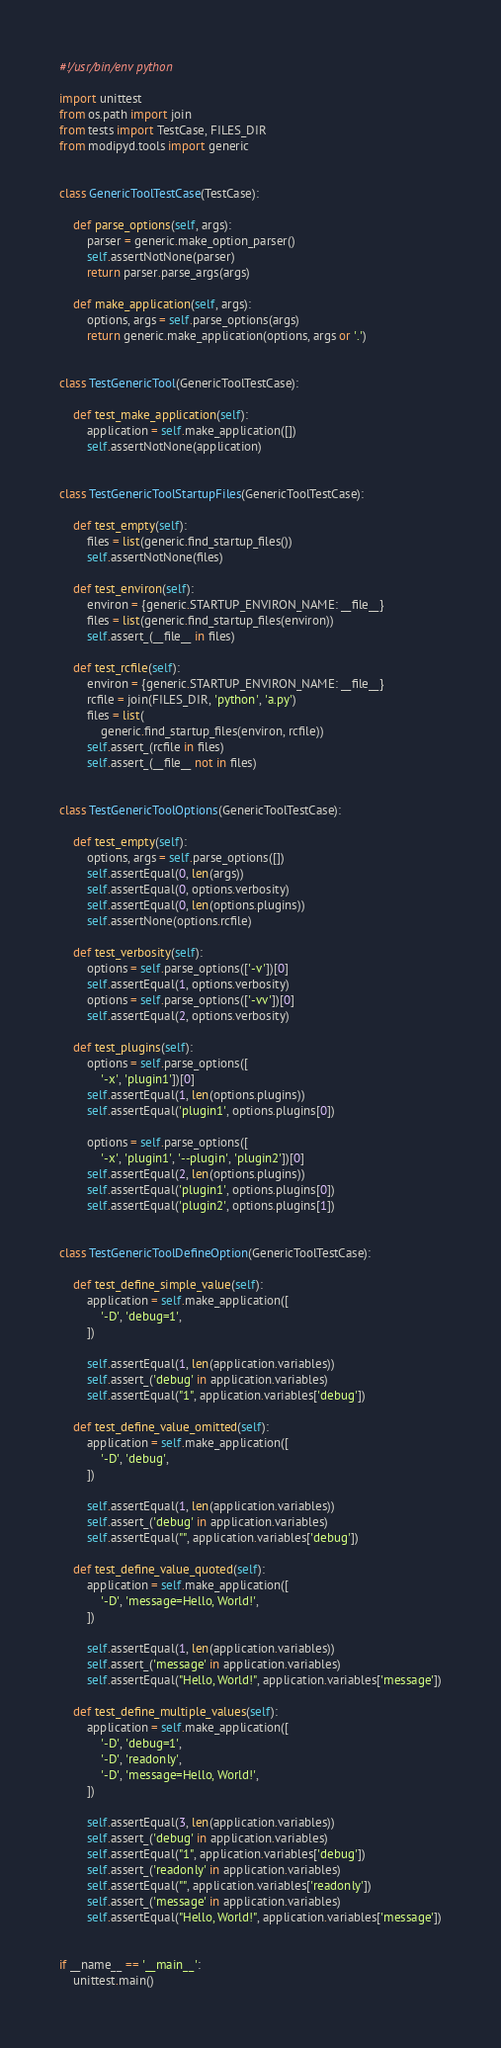<code> <loc_0><loc_0><loc_500><loc_500><_Python_>#!/usr/bin/env python

import unittest
from os.path import join
from tests import TestCase, FILES_DIR
from modipyd.tools import generic


class GenericToolTestCase(TestCase):

    def parse_options(self, args):
        parser = generic.make_option_parser()
        self.assertNotNone(parser)
        return parser.parse_args(args)

    def make_application(self, args):
        options, args = self.parse_options(args)
        return generic.make_application(options, args or '.')


class TestGenericTool(GenericToolTestCase):

    def test_make_application(self):
        application = self.make_application([])
        self.assertNotNone(application)


class TestGenericToolStartupFiles(GenericToolTestCase):

    def test_empty(self):
        files = list(generic.find_startup_files())
        self.assertNotNone(files)

    def test_environ(self):
        environ = {generic.STARTUP_ENVIRON_NAME: __file__}
        files = list(generic.find_startup_files(environ))
        self.assert_(__file__ in files)

    def test_rcfile(self):
        environ = {generic.STARTUP_ENVIRON_NAME: __file__}
        rcfile = join(FILES_DIR, 'python', 'a.py')
        files = list(
            generic.find_startup_files(environ, rcfile))
        self.assert_(rcfile in files)
        self.assert_(__file__ not in files)


class TestGenericToolOptions(GenericToolTestCase):

    def test_empty(self):
        options, args = self.parse_options([])
        self.assertEqual(0, len(args))
        self.assertEqual(0, options.verbosity)
        self.assertEqual(0, len(options.plugins))
        self.assertNone(options.rcfile)

    def test_verbosity(self):
        options = self.parse_options(['-v'])[0]
        self.assertEqual(1, options.verbosity)
        options = self.parse_options(['-vv'])[0]
        self.assertEqual(2, options.verbosity)

    def test_plugins(self):
        options = self.parse_options([
            '-x', 'plugin1'])[0]
        self.assertEqual(1, len(options.plugins))
        self.assertEqual('plugin1', options.plugins[0])

        options = self.parse_options([
            '-x', 'plugin1', '--plugin', 'plugin2'])[0]
        self.assertEqual(2, len(options.plugins))
        self.assertEqual('plugin1', options.plugins[0])
        self.assertEqual('plugin2', options.plugins[1])


class TestGenericToolDefineOption(GenericToolTestCase):

    def test_define_simple_value(self):
        application = self.make_application([
            '-D', 'debug=1',
        ])

        self.assertEqual(1, len(application.variables))
        self.assert_('debug' in application.variables)
        self.assertEqual("1", application.variables['debug'])

    def test_define_value_omitted(self):
        application = self.make_application([
            '-D', 'debug',
        ])

        self.assertEqual(1, len(application.variables))
        self.assert_('debug' in application.variables)
        self.assertEqual("", application.variables['debug'])

    def test_define_value_quoted(self):
        application = self.make_application([
            '-D', 'message=Hello, World!',
        ])

        self.assertEqual(1, len(application.variables))
        self.assert_('message' in application.variables)
        self.assertEqual("Hello, World!", application.variables['message'])

    def test_define_multiple_values(self):
        application = self.make_application([
            '-D', 'debug=1',
            '-D', 'readonly',
            '-D', 'message=Hello, World!',
        ])

        self.assertEqual(3, len(application.variables))
        self.assert_('debug' in application.variables)
        self.assertEqual("1", application.variables['debug'])
        self.assert_('readonly' in application.variables)
        self.assertEqual("", application.variables['readonly'])
        self.assert_('message' in application.variables)
        self.assertEqual("Hello, World!", application.variables['message'])


if __name__ == '__main__':
    unittest.main()
</code> 